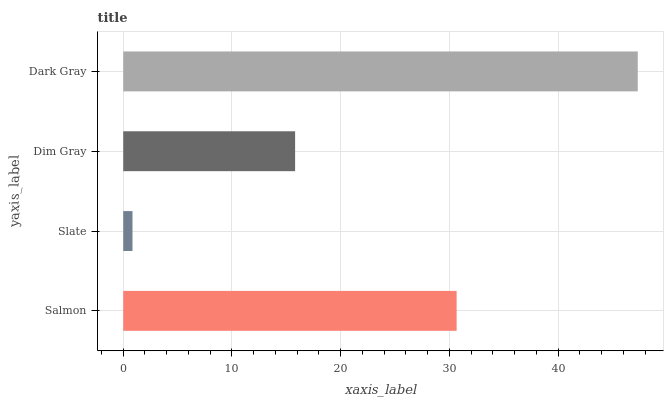Is Slate the minimum?
Answer yes or no. Yes. Is Dark Gray the maximum?
Answer yes or no. Yes. Is Dim Gray the minimum?
Answer yes or no. No. Is Dim Gray the maximum?
Answer yes or no. No. Is Dim Gray greater than Slate?
Answer yes or no. Yes. Is Slate less than Dim Gray?
Answer yes or no. Yes. Is Slate greater than Dim Gray?
Answer yes or no. No. Is Dim Gray less than Slate?
Answer yes or no. No. Is Salmon the high median?
Answer yes or no. Yes. Is Dim Gray the low median?
Answer yes or no. Yes. Is Slate the high median?
Answer yes or no. No. Is Salmon the low median?
Answer yes or no. No. 